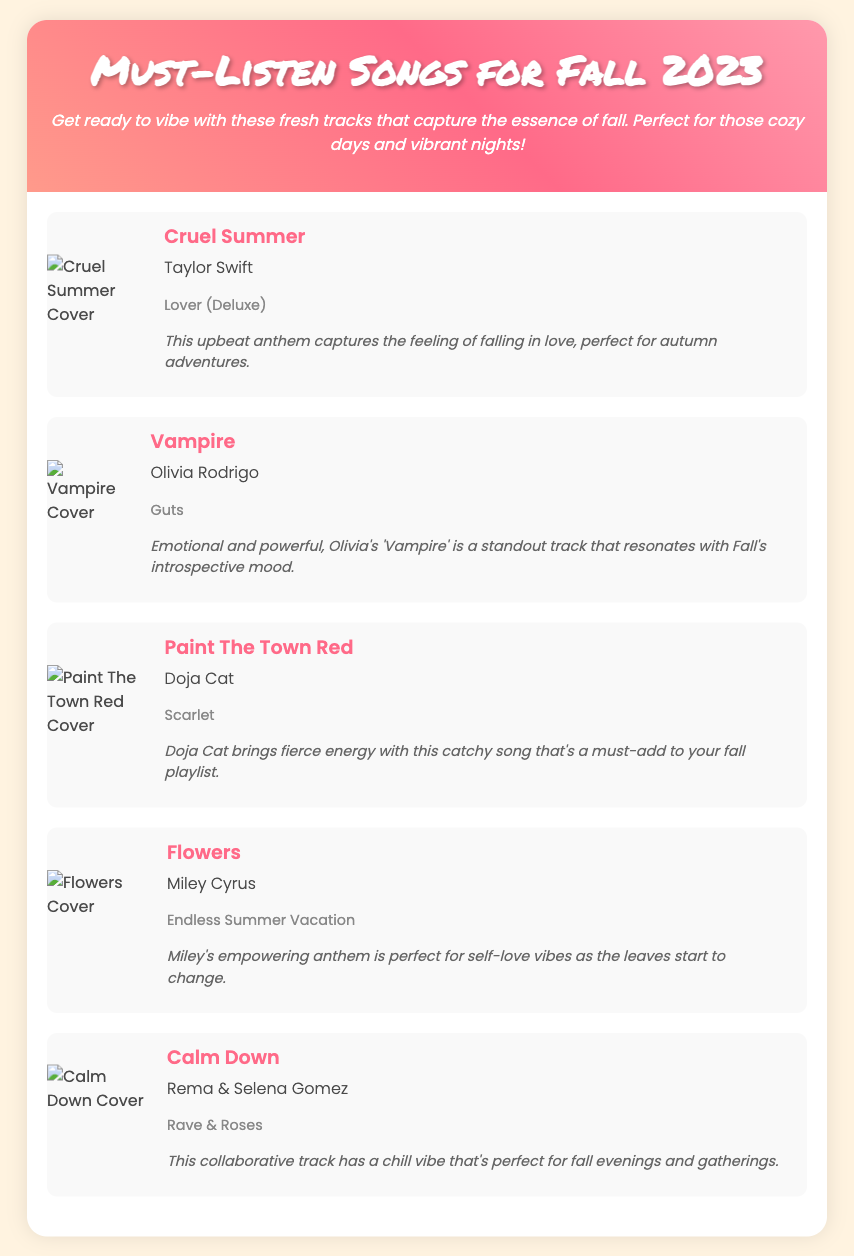what is the title of the playlist? The title is presented in the header of the document.
Answer: Must-Listen Songs for Fall 2023 who is the artist of "Cruel Summer"? The artist is listed under the song title within the song section.
Answer: Taylor Swift how many songs are featured in the playlist? The count can be determined by counting the number of song sections in the document.
Answer: Five which song is described as an empowering anthem? The description mentions empowerment in relation to one of the songs.
Answer: Flowers what is the album name for "Calm Down"? The album name is provided alongside the artist in the song's information section.
Answer: Rave & Roses which artist collaborates with Selena Gomez in "Calm Down"? The collaboration details are found in the song information section.
Answer: Rema what is the highlight of "Vampire"? The highlight provides a summary or insight into the song.
Answer: Emotional and powerful, Olivia's 'Vampire' is a standout track that resonates with Fall's introspective mood which song has the cover art containing a floral theme? The cover art theme relates to the song title which includes "Flowers".
Answer: Flowers 